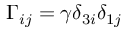<formula> <loc_0><loc_0><loc_500><loc_500>\Gamma _ { i j } = \gamma \delta _ { 3 i } \delta _ { 1 j }</formula> 